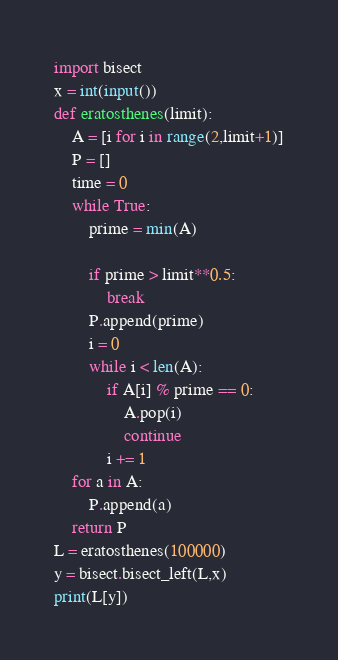<code> <loc_0><loc_0><loc_500><loc_500><_Python_>import bisect
x = int(input())
def eratosthenes(limit):
    A = [i for i in range(2,limit+1)]
    P = []
    time = 0
    while True:
        prime = min(A)
        
        if prime > limit**0.5:
            break
        P.append(prime)
        i = 0
        while i < len(A):
            if A[i] % prime == 0:
                A.pop(i)
                continue
            i += 1
    for a in A:
        P.append(a)
    return P
L = eratosthenes(100000)
y = bisect.bisect_left(L,x)
print(L[y])</code> 